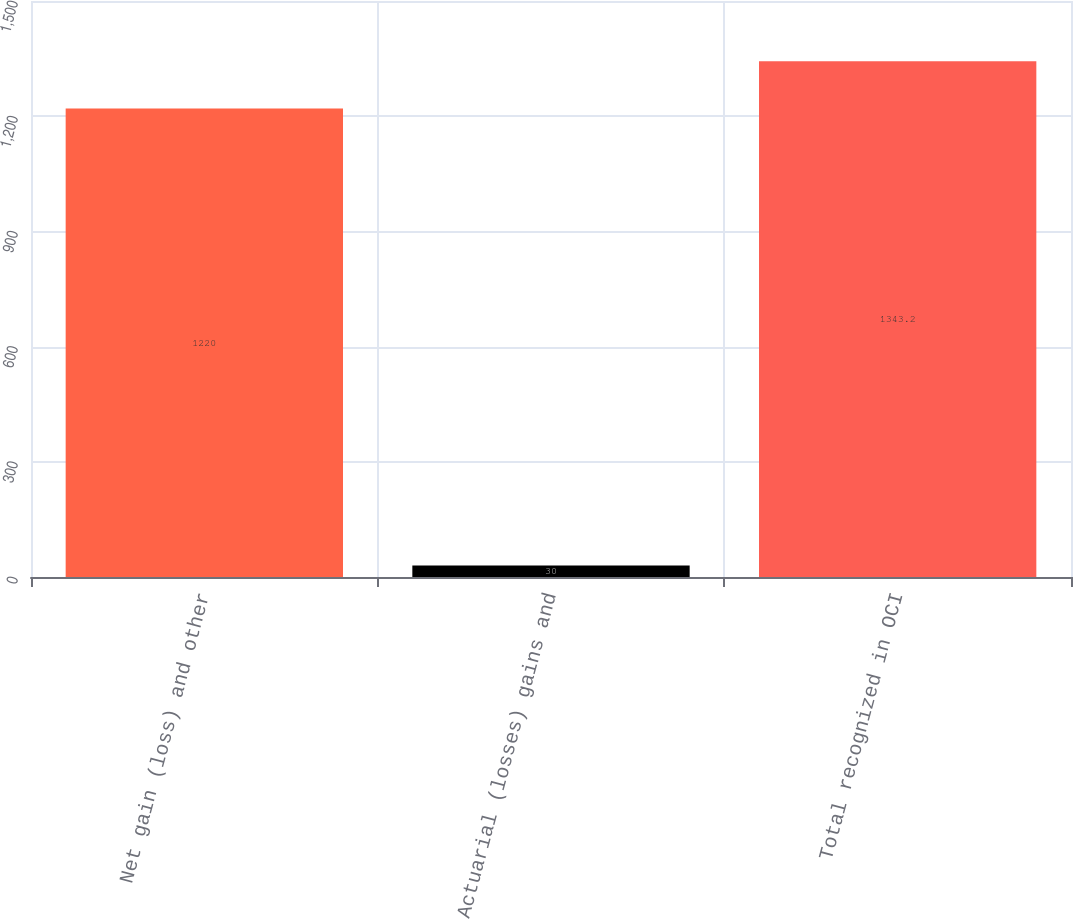Convert chart. <chart><loc_0><loc_0><loc_500><loc_500><bar_chart><fcel>Net gain (loss) and other<fcel>Actuarial (losses) gains and<fcel>Total recognized in OCI<nl><fcel>1220<fcel>30<fcel>1343.2<nl></chart> 